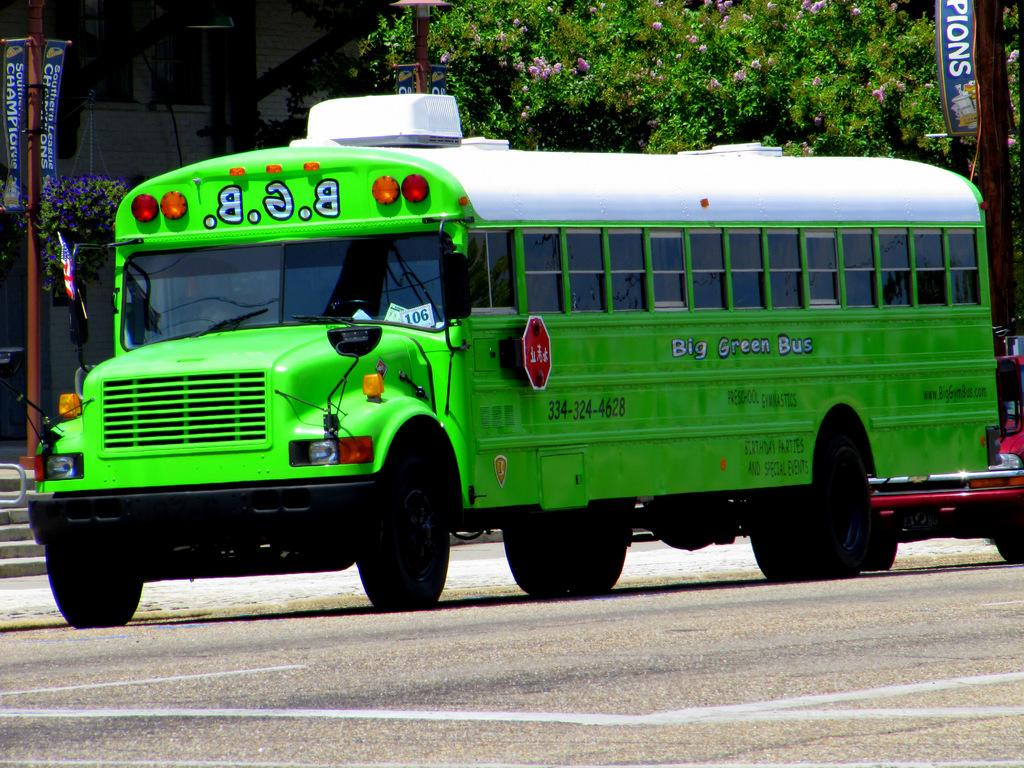What type of vehicle is in the image? There is a bus in the image. What colors can be seen on the bus? The bus is green and white in color. What other type of vehicle is in the image? There is a car in the image. What color is the car? The car is red in color. What type of structure is in the image? There is a building in the image. What type of plant is in the image? There is a tree in the image. What else can be seen in the image? There are banners on poles in the image. What type of crime is being committed in the image? There is no crime being committed in the image; it features a bus, a car, a building, a tree, and banners on poles. What scent can be detected in the image? There is no mention of any scent in the image; it focuses on visual elements. 